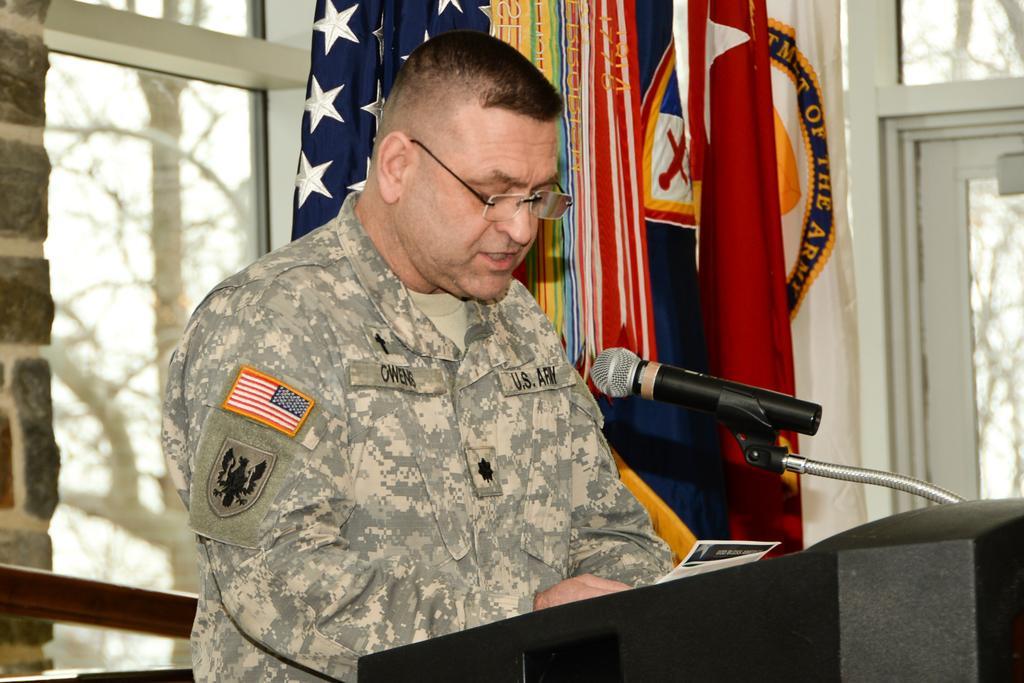Please provide a concise description of this image. In the center of the image there is a person standing at the desk. On the desk we can see mic. In the background we can see flags, windows, trees and wall. 